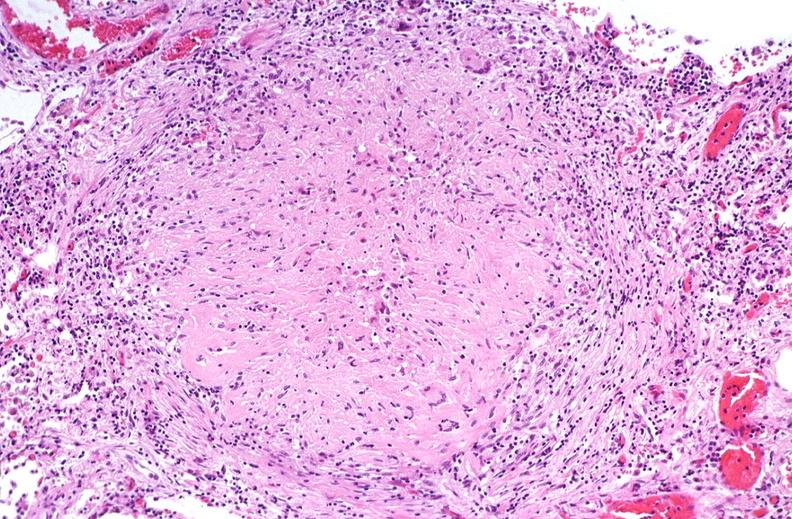does clostridial postmortem growth show lung, mycobacterium tuberculosis, granulomas and giant cells?
Answer the question using a single word or phrase. No 